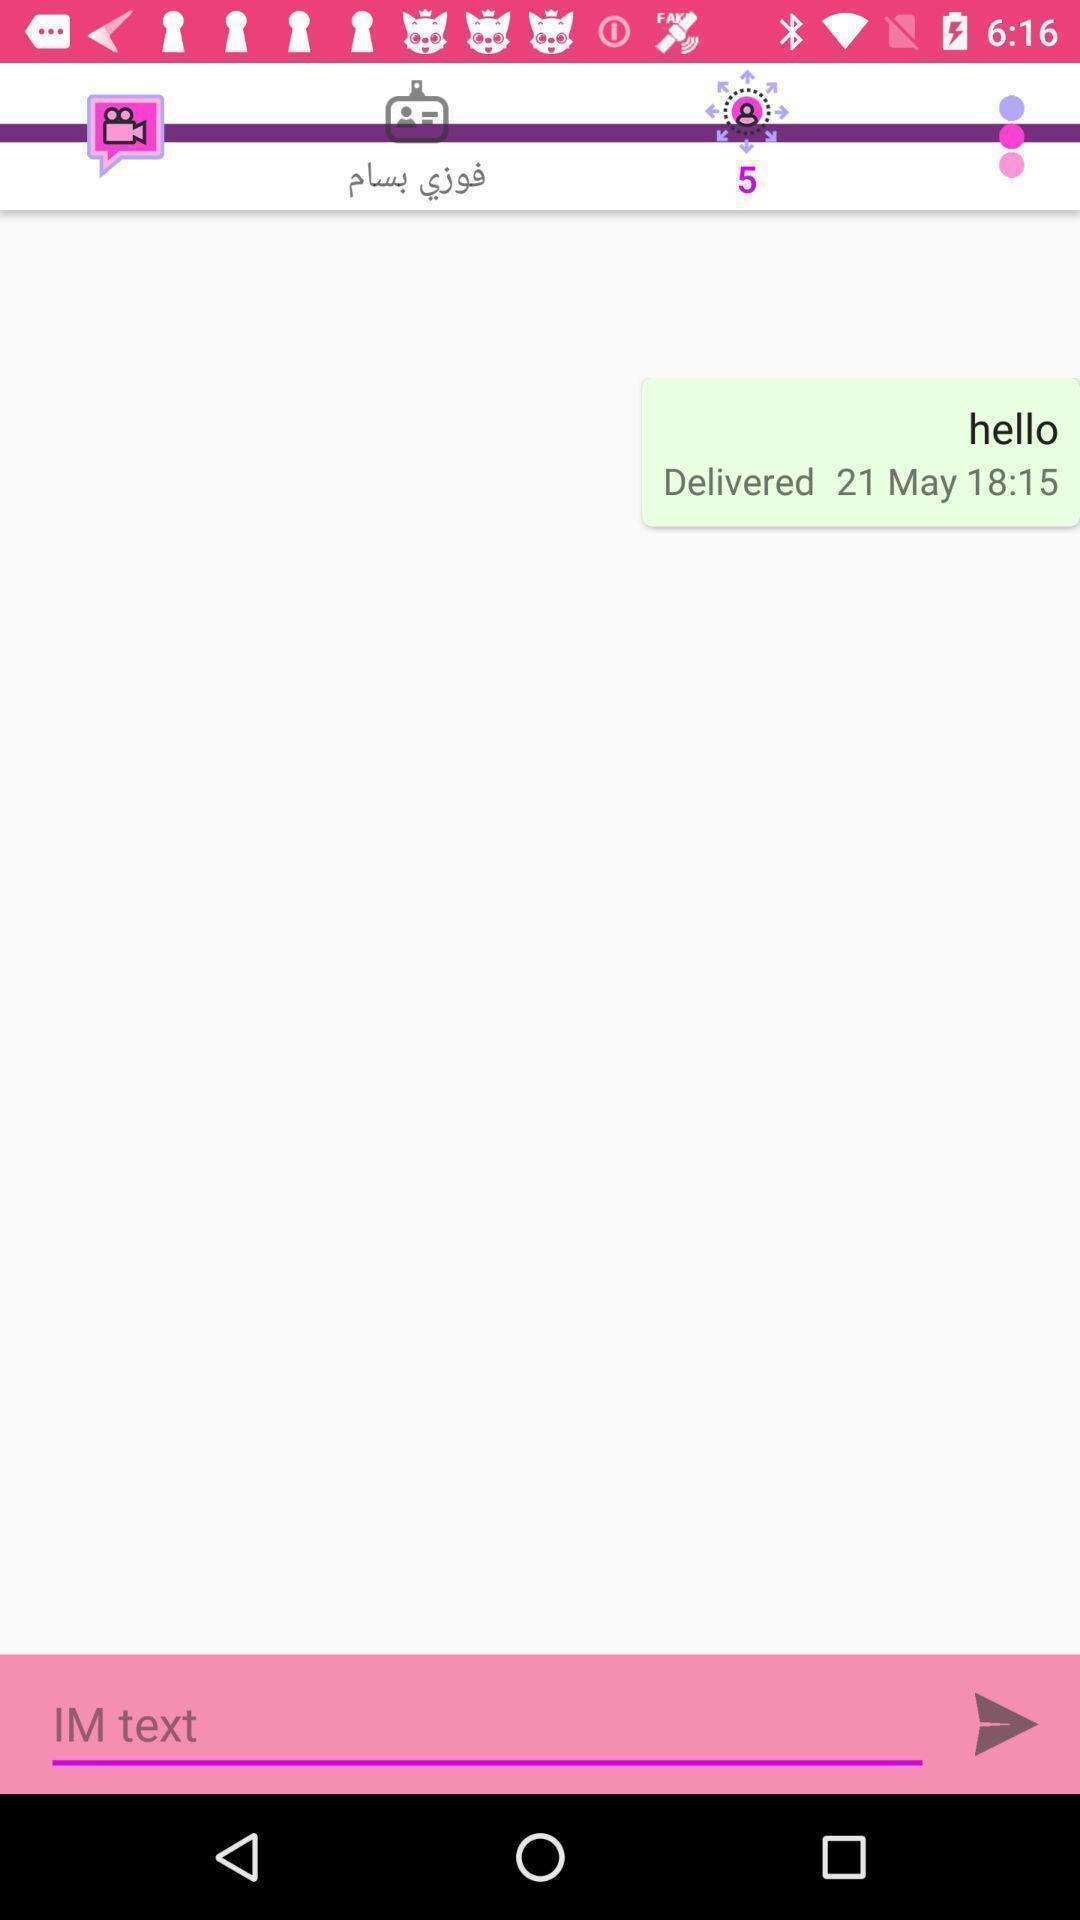Describe the key features of this screenshot. Screen displaying chat box. 